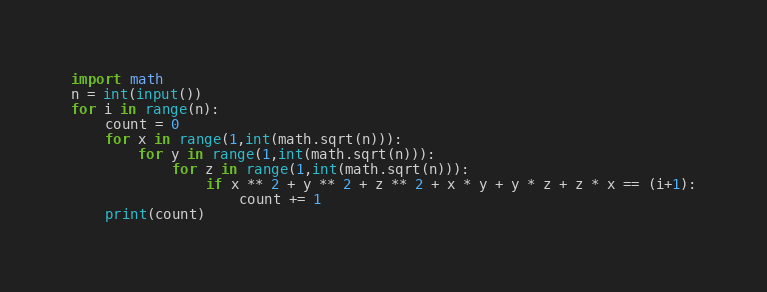Convert code to text. <code><loc_0><loc_0><loc_500><loc_500><_Python_>import math
n = int(input())
for i in range(n):
    count = 0
    for x in range(1,int(math.sqrt(n))):
        for y in range(1,int(math.sqrt(n))):
            for z in range(1,int(math.sqrt(n))):
                if x ** 2 + y ** 2 + z ** 2 + x * y + y * z + z * x == (i+1):
                    count += 1
    print(count)</code> 